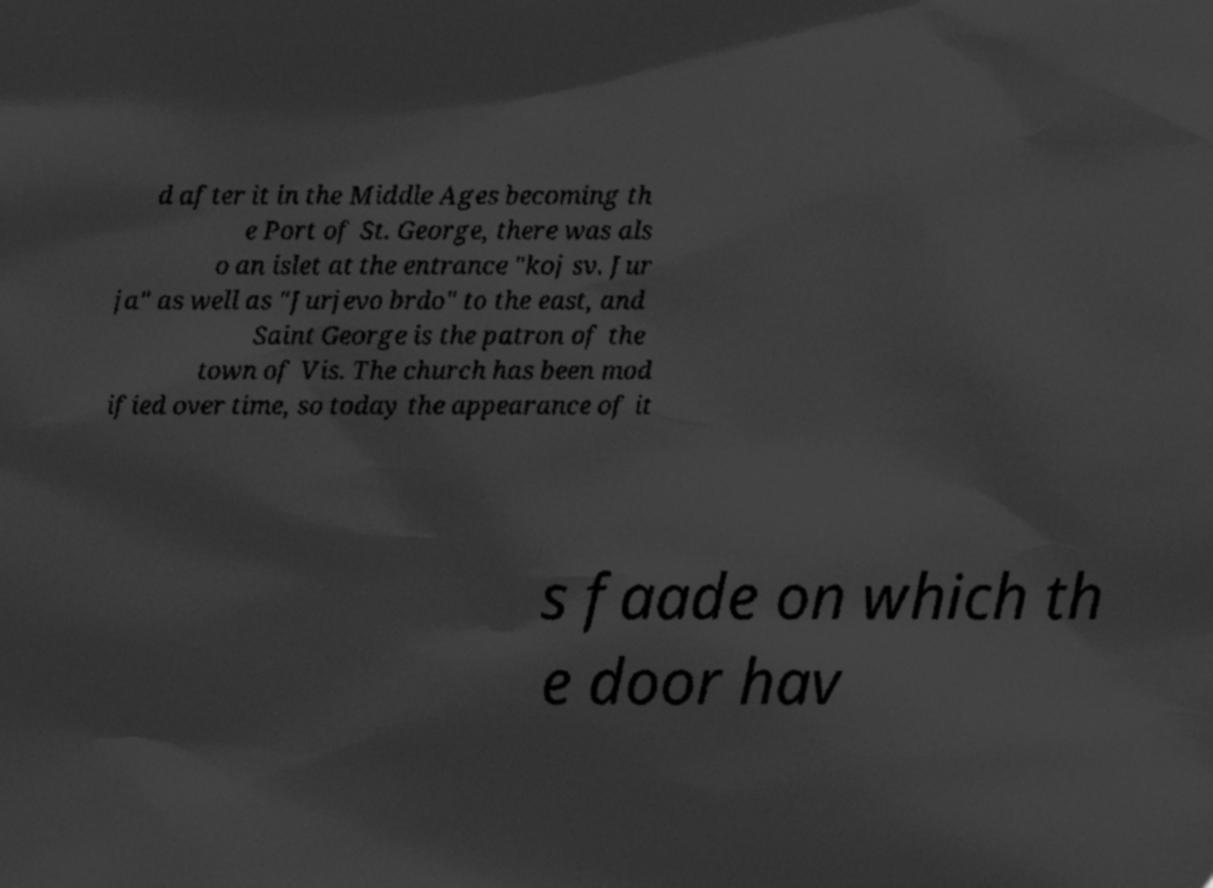Can you accurately transcribe the text from the provided image for me? d after it in the Middle Ages becoming th e Port of St. George, there was als o an islet at the entrance "koj sv. Jur ja" as well as "Jurjevo brdo" to the east, and Saint George is the patron of the town of Vis. The church has been mod ified over time, so today the appearance of it s faade on which th e door hav 